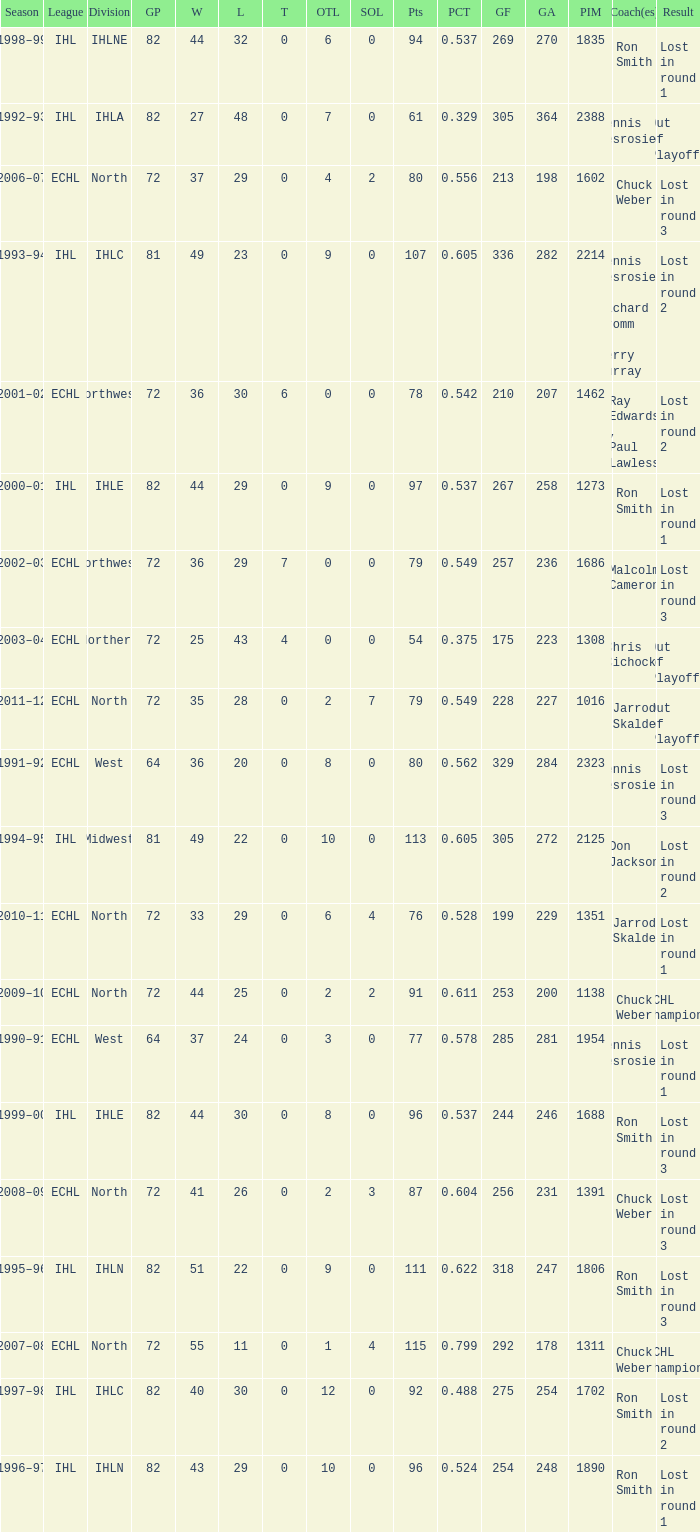What was the highest SOL where the team lost in round 3? 3.0. 